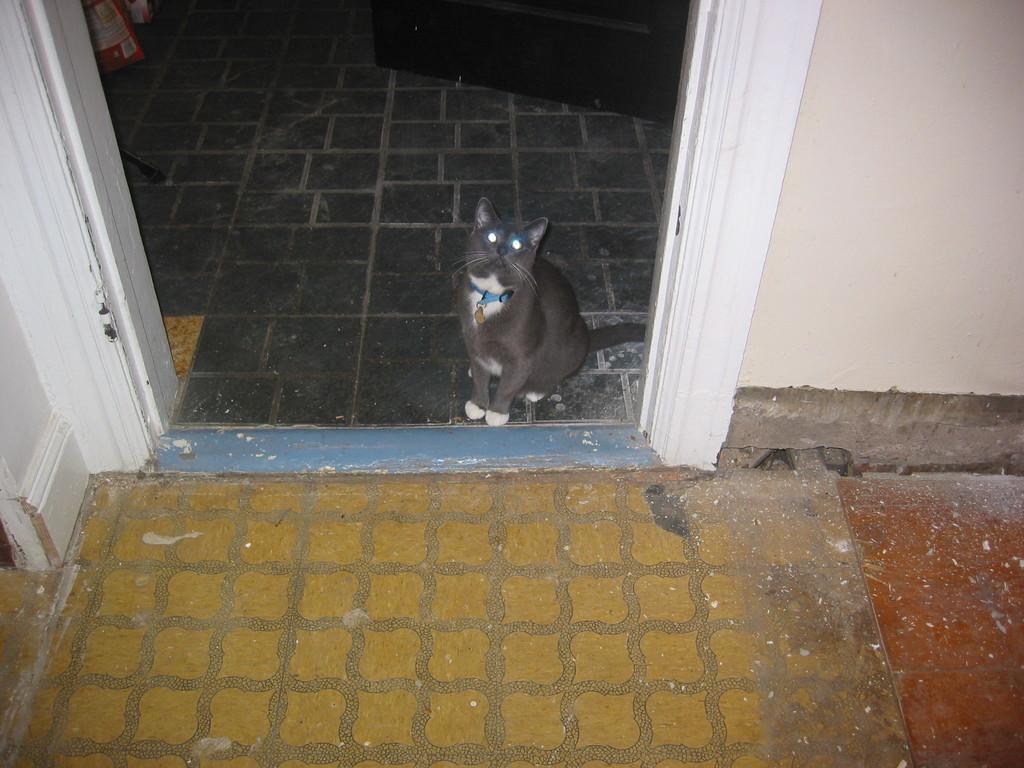Describe this image in one or two sentences. In this picture I can see a cat, there is a wall, and in the background there are some objects. 